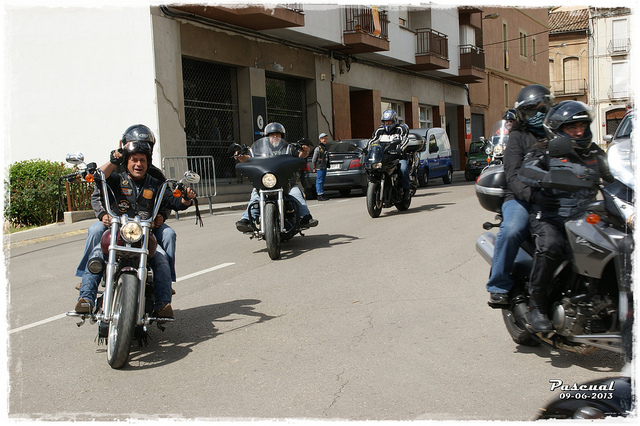Identify the text contained in this image. Pascual 09-06-2013 